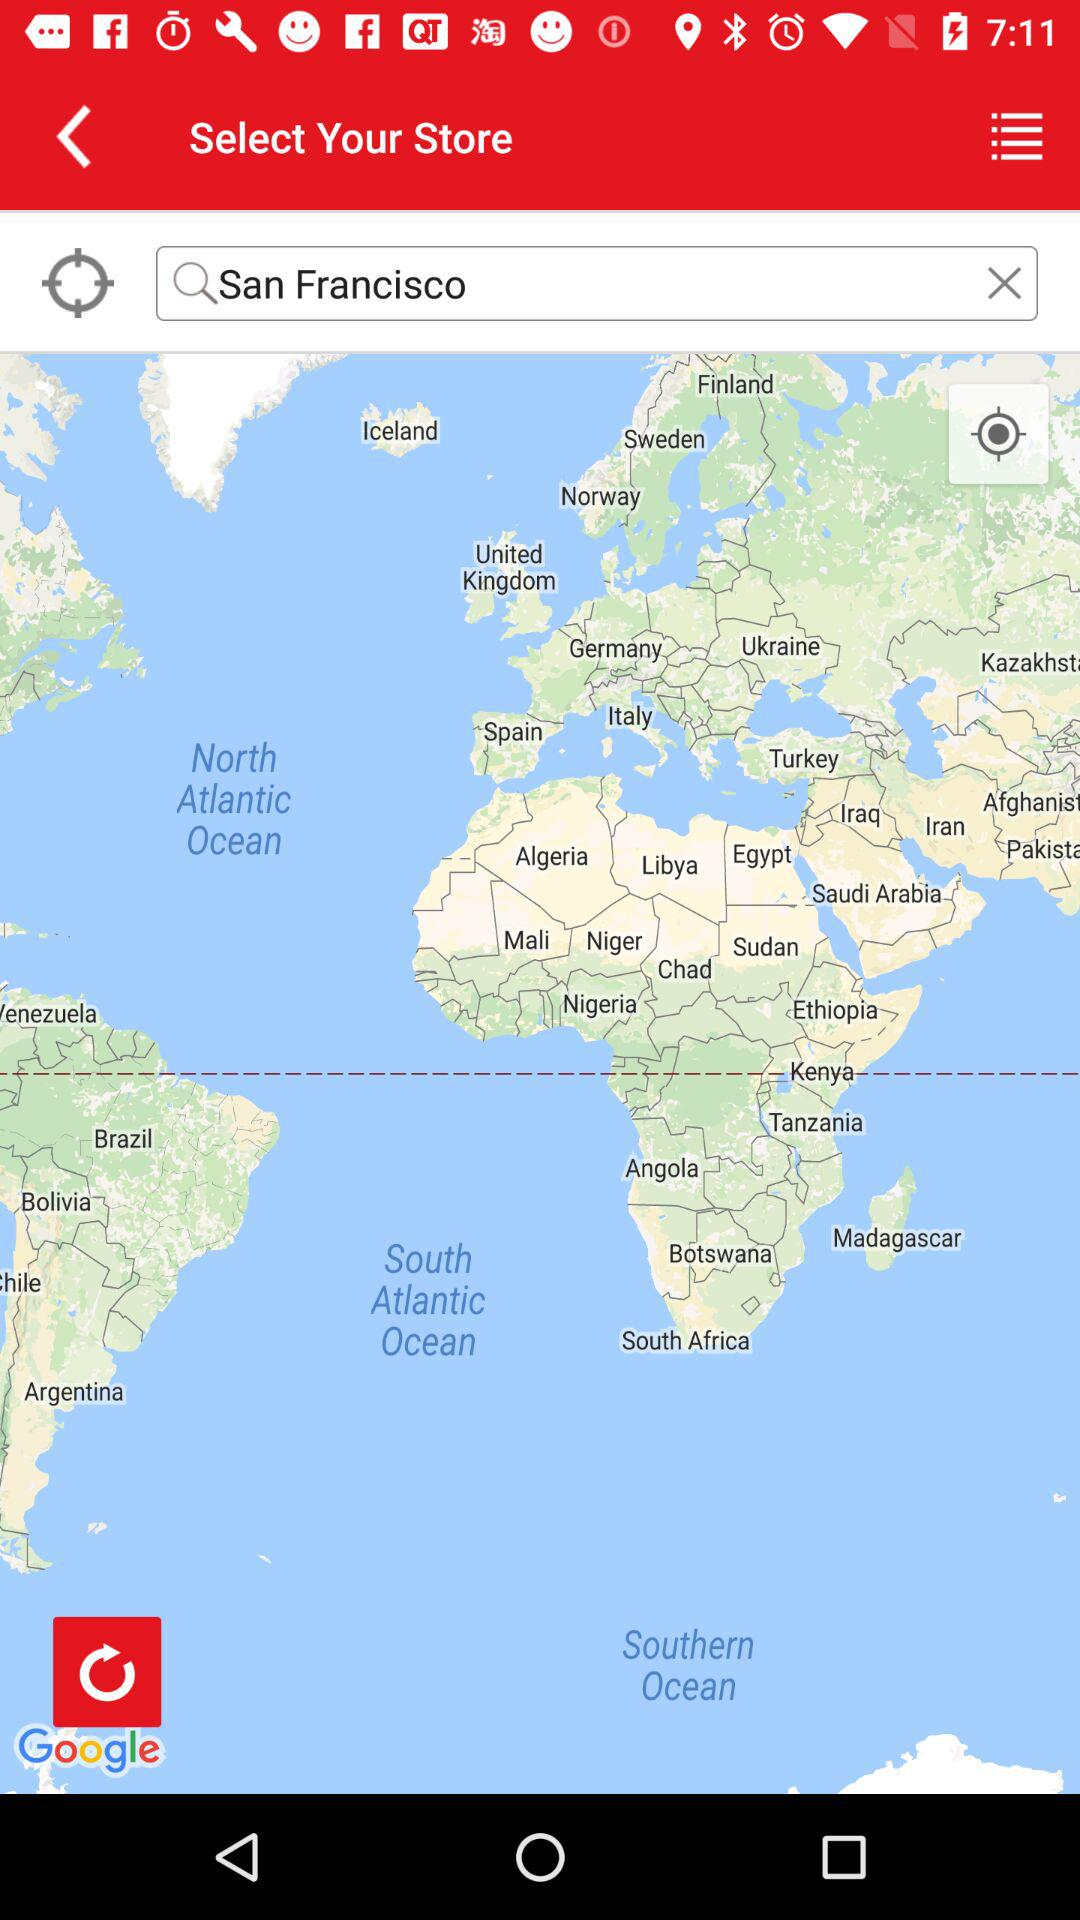What is the name of the city? The city is San Francisco. 